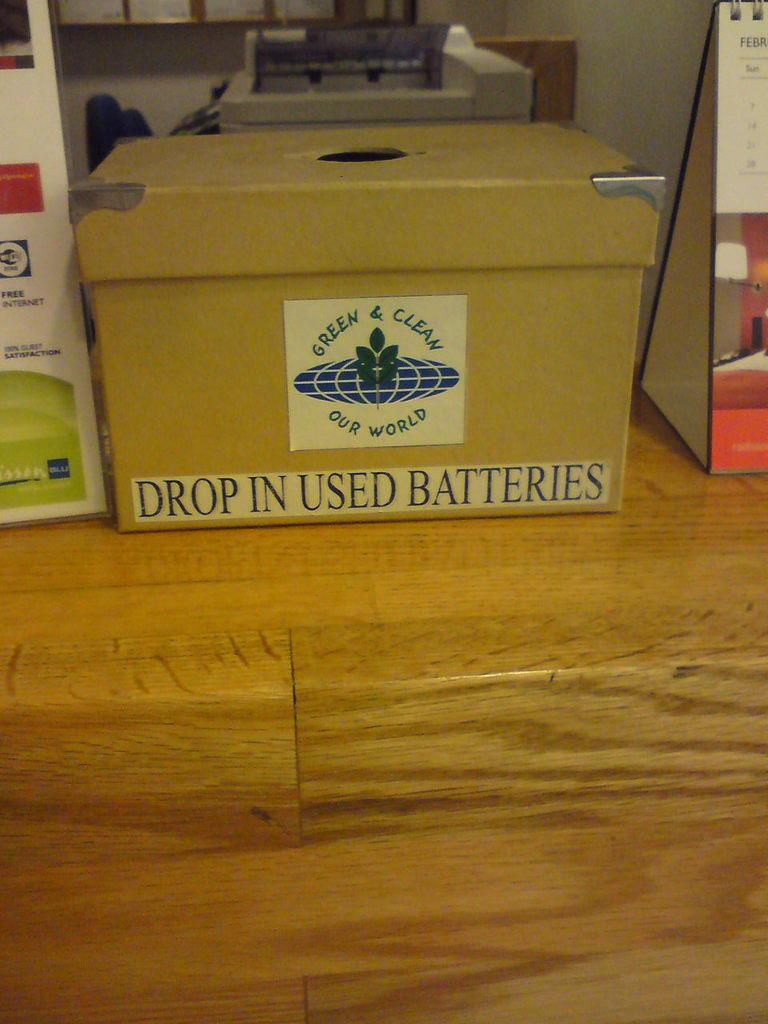<image>
Offer a succinct explanation of the picture presented. a box with a label on it that states 'drop in used batteries' 